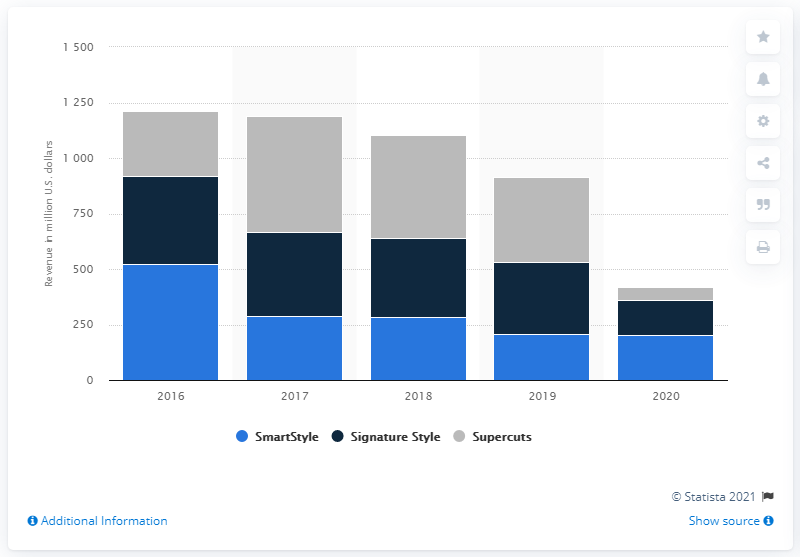Highlight a few significant elements in this photo. In the fiscal year of 2020, the Supercuts brand generated a total revenue of 54.12. 